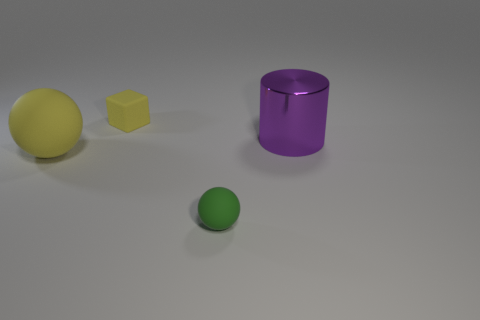Is there any other thing that has the same material as the large purple thing?
Give a very brief answer. No. There is a big thing that is on the left side of the tiny sphere; does it have the same shape as the green object?
Offer a very short reply. Yes. Do the big matte thing and the green object have the same shape?
Provide a succinct answer. Yes. Are there any small objects of the same shape as the big yellow thing?
Keep it short and to the point. Yes. There is a yellow rubber object that is in front of the yellow object that is behind the purple metallic cylinder; what is its shape?
Keep it short and to the point. Sphere. There is a big thing that is on the left side of the tiny green ball; what color is it?
Make the answer very short. Yellow. What is the size of the other yellow object that is the same material as the tiny yellow thing?
Provide a succinct answer. Large. The yellow thing that is the same shape as the small green thing is what size?
Your answer should be very brief. Large. Is there a block?
Ensure brevity in your answer.  Yes. How many things are either small objects that are behind the large shiny cylinder or small purple cylinders?
Your response must be concise. 1. 